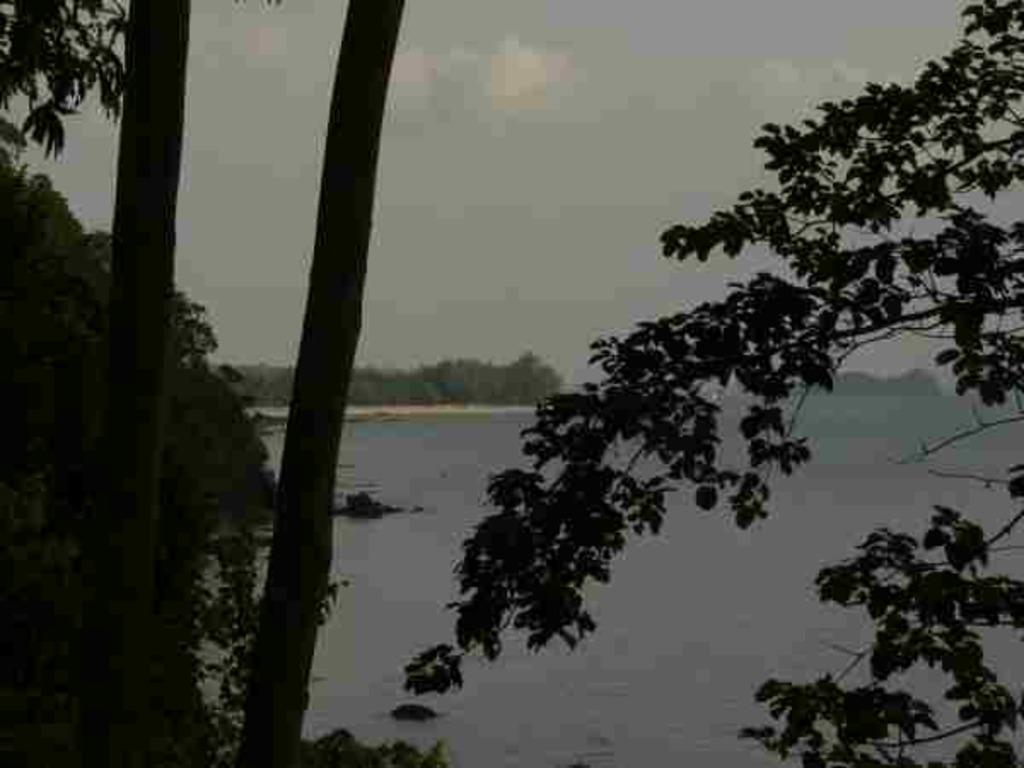What type of natural environment is depicted in the image? There is a sea in the image. What other natural elements can be seen in the image? There are trees in the image. What is visible above the sea and trees in the image? The sky is visible in the image. What can be observed in the sky in the image? Clouds are present in the sky. Can you see a hook in the sea in the image? There is no hook visible in the sea in the image. 